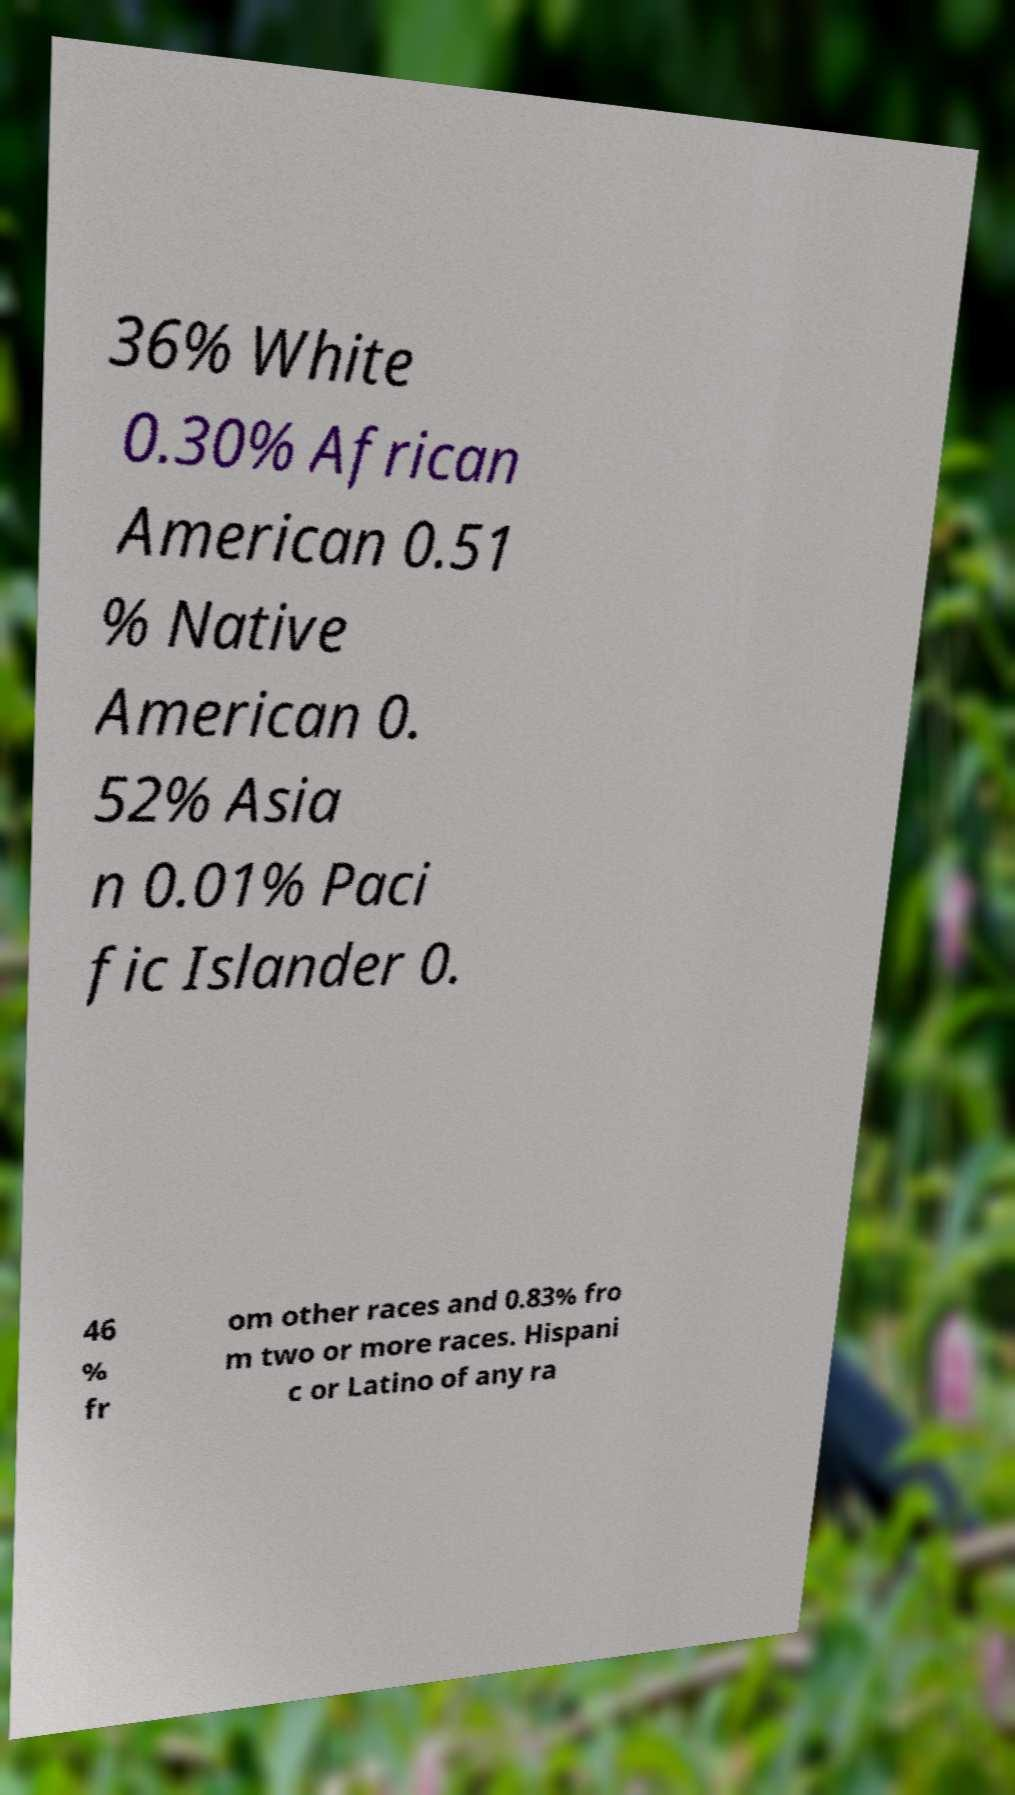Please identify and transcribe the text found in this image. 36% White 0.30% African American 0.51 % Native American 0. 52% Asia n 0.01% Paci fic Islander 0. 46 % fr om other races and 0.83% fro m two or more races. Hispani c or Latino of any ra 